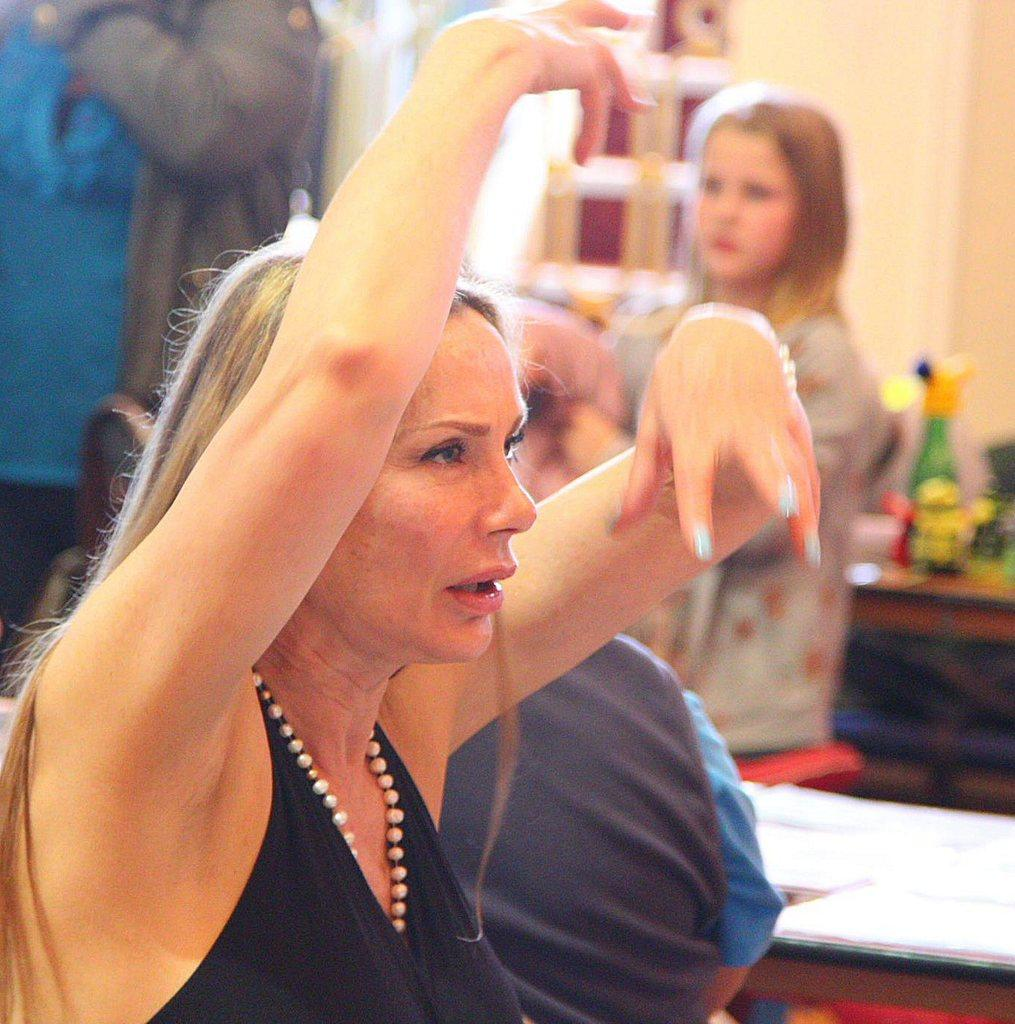Who is the main subject in the front of the image? There is a woman in the front of the image. What are the people in the background doing? There are persons standing and sitting in the background of the image. What else can be seen in the background of the image? There are objects and a wall in the background of the image. Can you see a river flowing in the background of the image? There is no river visible in the background of the image. Are there any bubbles floating around the woman in the image? There are no bubbles present in the image. 